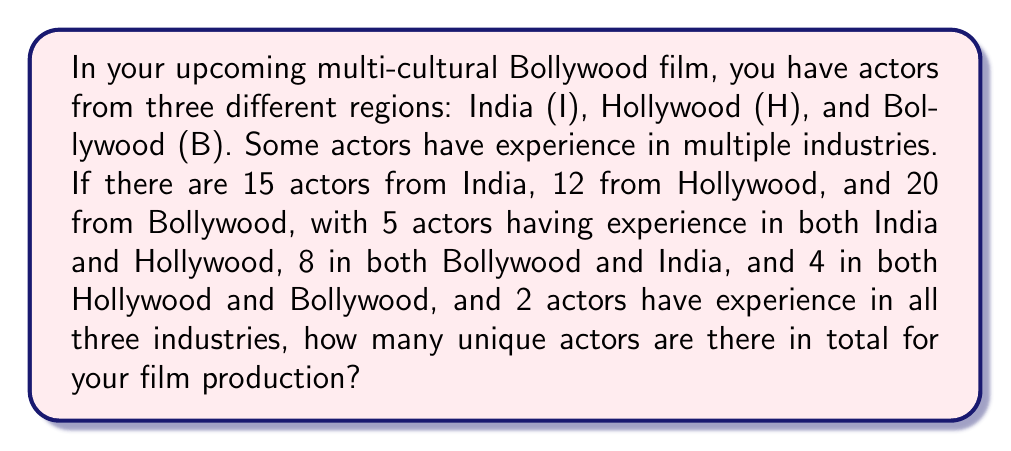What is the answer to this math problem? Let's approach this problem using set theory:

1) First, let's define our sets:
   I = actors from India
   H = actors from Hollywood
   B = actors from Bollywood

2) We're given:
   $|I| = 15$, $|H| = 12$, $|B| = 20$
   $|I \cap H| = 5$, $|B \cap I| = 8$, $|H \cap B| = 4$
   $|I \cap H \cap B| = 2$

3) We need to find $|I \cup H \cup B|$. We can use the Inclusion-Exclusion Principle:

   $|I \cup H \cup B| = |I| + |H| + |B| - |I \cap H| - |I \cap B| - |H \cap B| + |I \cap H \cap B|$

4) Substituting the values:

   $|I \cup H \cup B| = 15 + 12 + 20 - 5 - 8 - 4 + 2$

5) Calculate:
   
   $|I \cup H \cup B| = 47 - 17 + 2 = 32$

Therefore, there are 32 unique actors in total for your film production.
Answer: 32 unique actors 